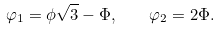Convert formula to latex. <formula><loc_0><loc_0><loc_500><loc_500>\varphi _ { 1 } = \phi \sqrt { 3 } - \Phi , \quad \varphi _ { 2 } = 2 \Phi .</formula> 